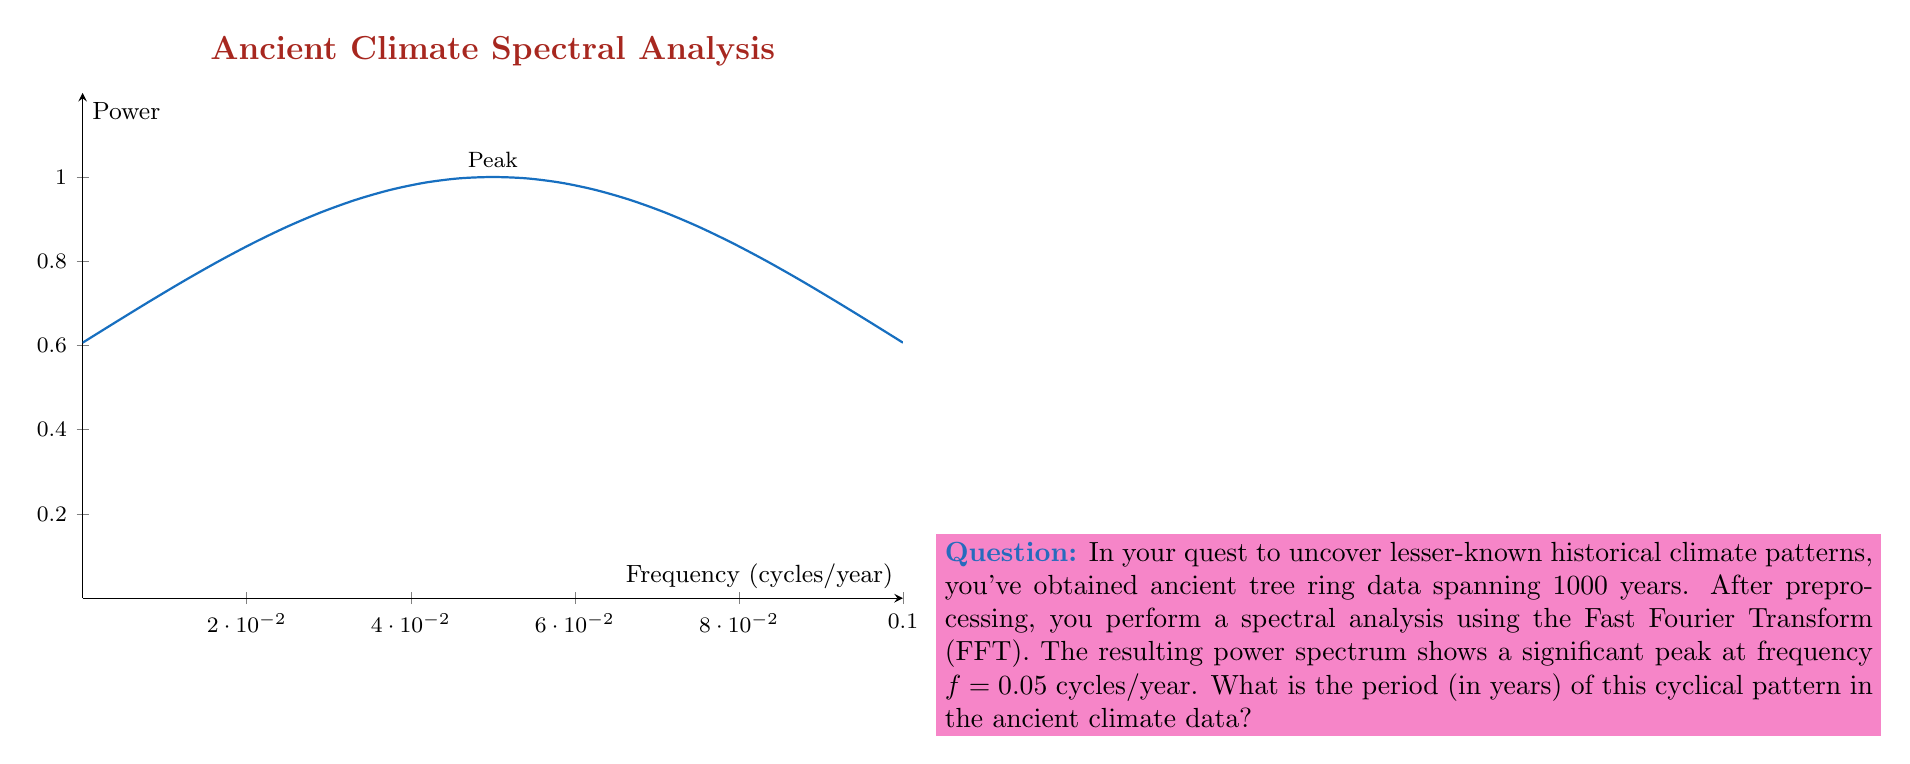Can you solve this math problem? To solve this problem, we need to understand the relationship between frequency and period in cyclical data:

1) The frequency ($f$) is given in cycles per year.
2) The period ($T$) is the time taken for one complete cycle.
3) The relationship between frequency and period is: $f = \frac{1}{T}$

Given:
- Frequency ($f$) = 0.05 cycles/year

Step 1: Use the formula $T = \frac{1}{f}$ to calculate the period.

$T = \frac{1}{f} = \frac{1}{0.05}$ cycles/year

Step 2: Simplify the fraction.

$T = 20$ years

Therefore, the cyclical pattern in the ancient climate data has a period of 20 years.
Answer: 20 years 